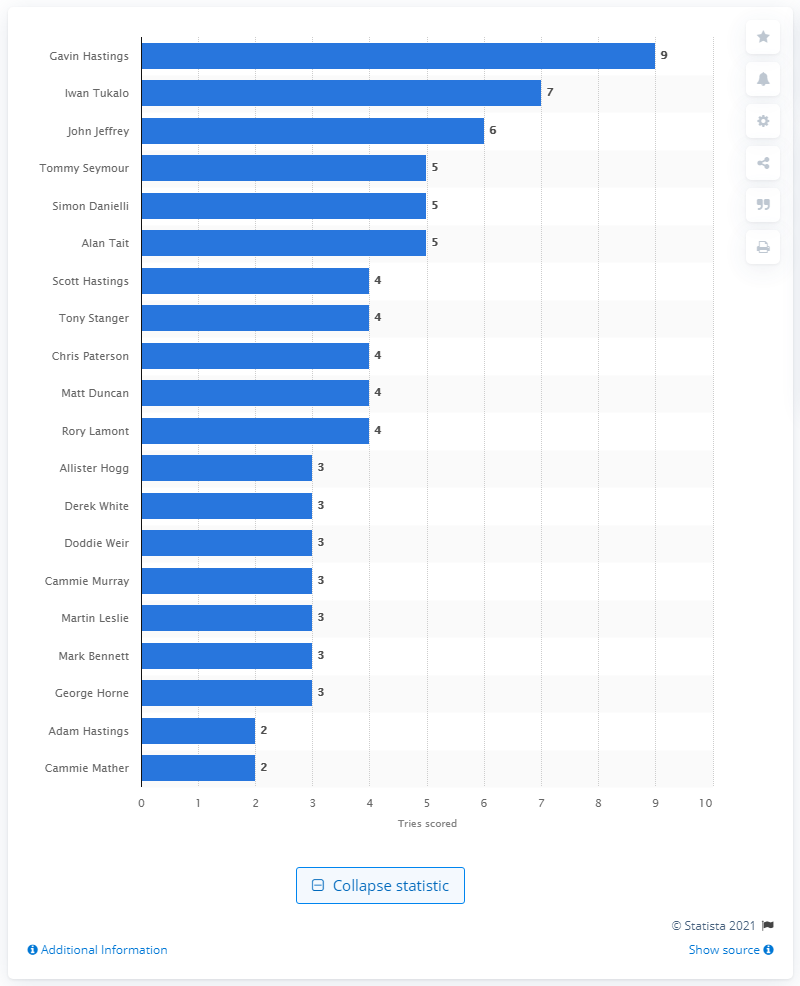Indicate a few pertinent items in this graphic. Gavin Hastings currently holds the record for the most tries scored at the Rugby World Cup with an impressive amount. Iwan Tukalo holds the record for the most tries scored at the Rugby World Cup, making him a notable player in the sport. 